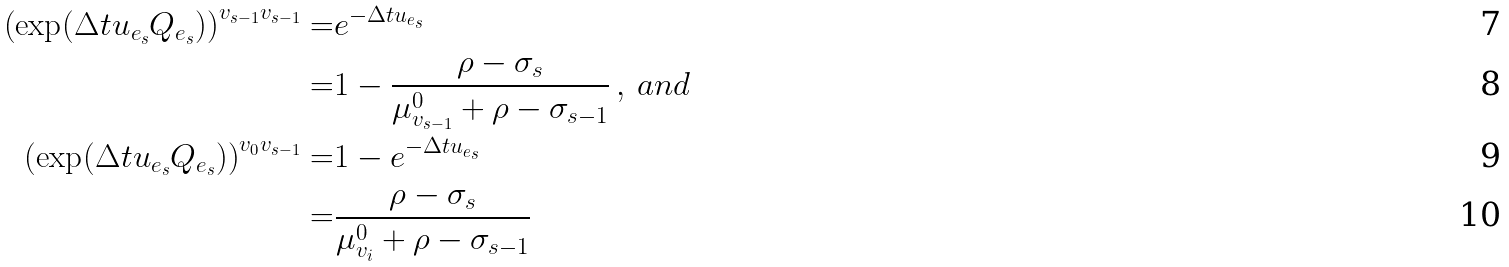<formula> <loc_0><loc_0><loc_500><loc_500>\left ( \exp ( \Delta t u _ { e _ { s } } Q _ { e _ { s } } ) \right ) ^ { v _ { s - 1 } v _ { s - 1 } } = & e ^ { - \Delta t u _ { e _ { s } } } \\ = & 1 - \frac { \rho - \sigma _ { s } } { \mu ^ { 0 } _ { v _ { s - 1 } } + \rho - \sigma _ { s - 1 } } \, , \, a n d \\ \left ( \exp ( \Delta t u _ { e _ { s } } Q _ { e _ { s } } ) \right ) ^ { v _ { 0 } v _ { s - 1 } } = & 1 - e ^ { - \Delta t u _ { e _ { s } } } \\ = & \frac { \rho - \sigma _ { s } } { \mu ^ { 0 } _ { v _ { i } } + \rho - \sigma _ { s - 1 } }</formula> 